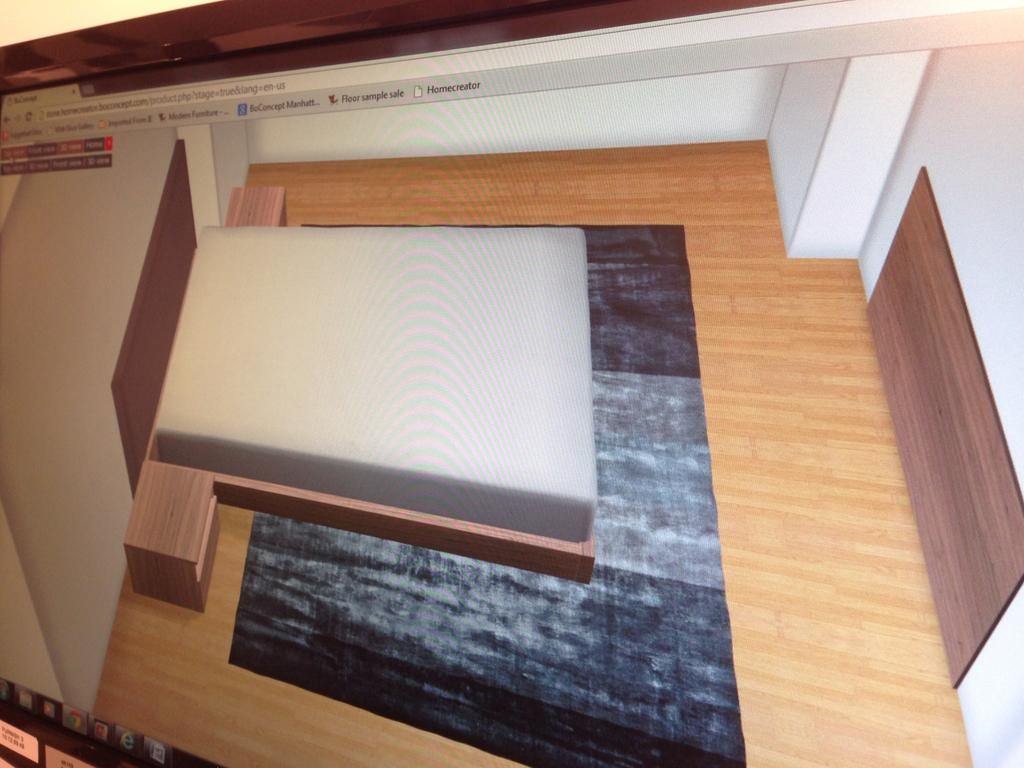What is the main object in the image? There is a display screen in the image. Can you describe the display screen in more detail? Unfortunately, the provided facts do not offer any additional details about the display screen. What type of insurance policy is being advertised on the display screen in the image? There is no information provided about the content of the display screen, so we cannot determine if any insurance policy is being advertised. 